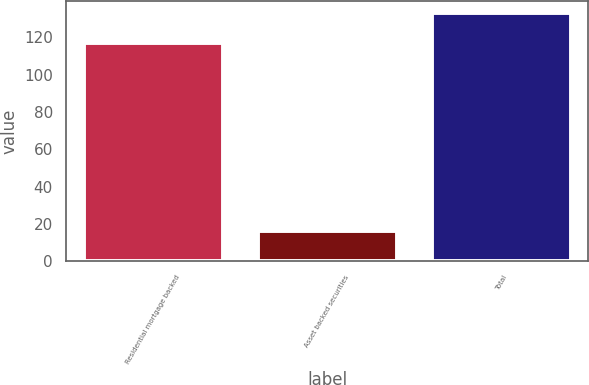Convert chart to OTSL. <chart><loc_0><loc_0><loc_500><loc_500><bar_chart><fcel>Residential mortgage backed<fcel>Asset backed securities<fcel>Total<nl><fcel>117<fcel>16<fcel>133<nl></chart> 